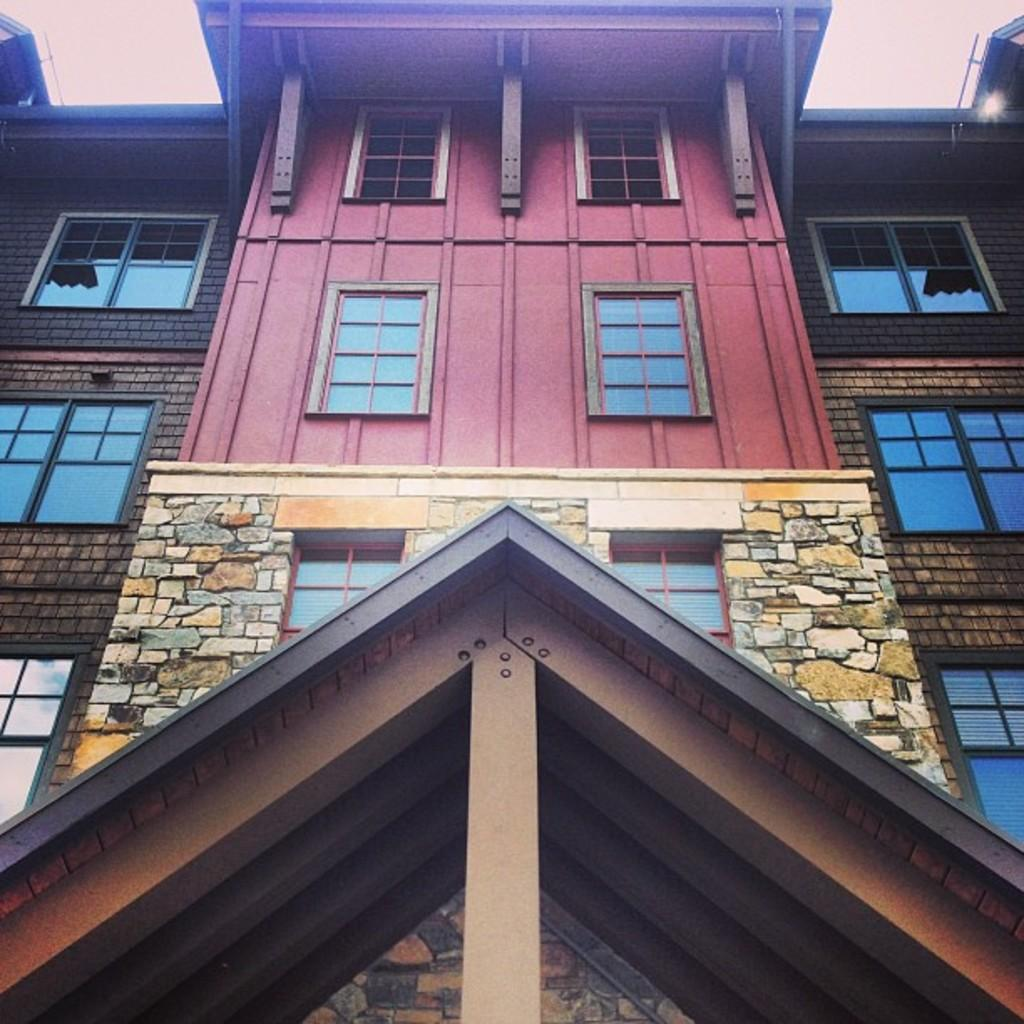What is the main subject of the picture? The main subject of the picture is a building. What specific features can be seen on the building? The building has windows. What can be seen in the background of the picture? The sky is visible in the background of the picture. How many guitars are being played in the picture? There are no guitars present in the picture; it features a building with windows and a visible sky. What is the income of the person standing next to the building? There is no person standing next to the building in the picture, so their income cannot be determined. 